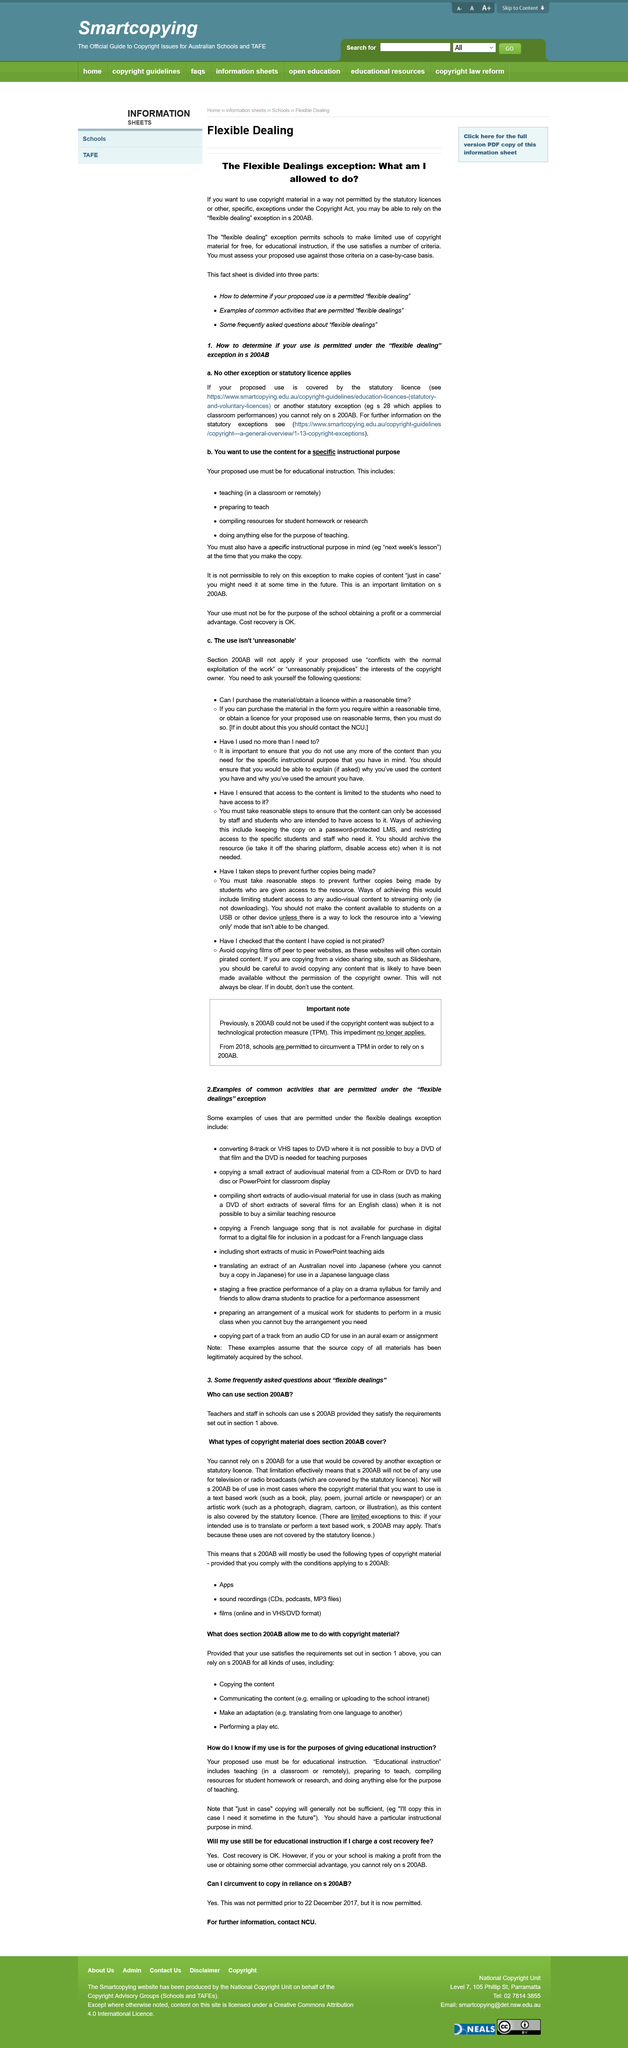Outline some significant characteristics in this image. There are four educational instructions included for the proposed use. It is not considered educational instruction to copy something with the intention of using it in the future, even if you may need it at some point. I can explain the amount and reasons for using the content I have used. The use of the 200AB code cannot be made if the copyrighted content was subject to a technological protection measure (TPM) as of December 31, 2020, according to the amendment to the Australian Copyright Act. It is imperative to ask yourself two questions before using any material or obtaining a license: 'Can I purchase the material/obtain a licence within a reasonable time?' and 'Have I used no more than I need to?' 